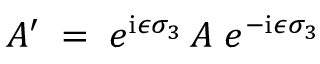Convert formula to latex. <formula><loc_0><loc_0><loc_500><loc_500>A ^ { \prime } \, = \, e ^ { i \epsilon \sigma _ { 3 } } \, A \, e ^ { - i \epsilon \sigma _ { 3 } }</formula> 